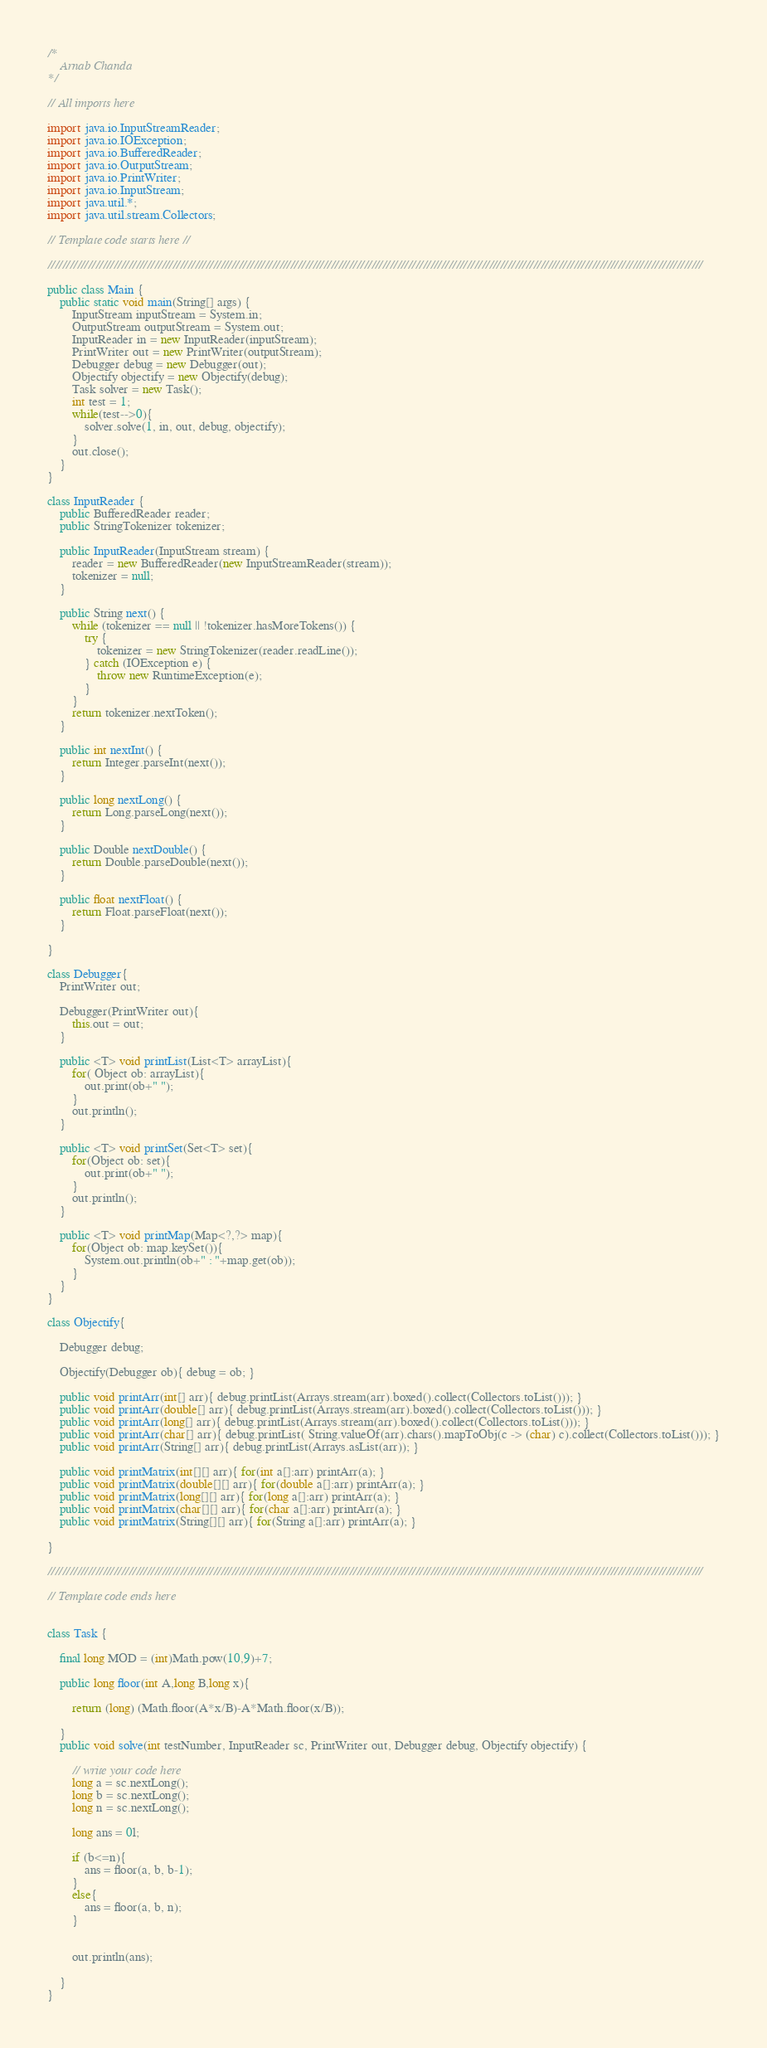<code> <loc_0><loc_0><loc_500><loc_500><_Java_>/*
    Arnab Chanda 
*/

// All imports here

import java.io.InputStreamReader;
import java.io.IOException;
import java.io.BufferedReader;
import java.io.OutputStream;
import java.io.PrintWriter;
import java.io.InputStream;
import java.util.*;
import java.util.stream.Collectors;

// Template code starts here //

//////////////////////////////////////////////////////////////////////////////////////////////////////////////////////////////////////////////////////////////////////////////////

public class Main {
	public static void main(String[] args) {
		InputStream inputStream = System.in;
		OutputStream outputStream = System.out;
		InputReader in = new InputReader(inputStream);
        PrintWriter out = new PrintWriter(outputStream);
        Debugger debug = new Debugger(out);
        Objectify objectify = new Objectify(debug);
        Task solver = new Task();
        int test = 1;
        while(test-->0){
            solver.solve(1, in, out, debug, objectify);
        }
		out.close();
	}
}

class InputReader {
    public BufferedReader reader;
    public StringTokenizer tokenizer;
 
    public InputReader(InputStream stream) {
        reader = new BufferedReader(new InputStreamReader(stream));
        tokenizer = null;
    }
 
    public String next() {
        while (tokenizer == null || !tokenizer.hasMoreTokens()) {
            try {
                tokenizer = new StringTokenizer(reader.readLine());
            } catch (IOException e) {
                throw new RuntimeException(e);
            }
        }
        return tokenizer.nextToken();
    }
 
    public int nextInt() {
        return Integer.parseInt(next());
    }

    public long nextLong() {
        return Long.parseLong(next());
    }

    public Double nextDouble() {
        return Double.parseDouble(next());
    }

    public float nextFloat() {
        return Float.parseFloat(next());
    }
 
}

class Debugger{
    PrintWriter out;

    Debugger(PrintWriter out){    
        this.out = out;
    }

    public <T> void printList(List<T> arrayList){
        for( Object ob: arrayList){
            out.print(ob+" ");
        }
        out.println();
    }

    public <T> void printSet(Set<T> set){
        for(Object ob: set){
            out.print(ob+" ");
        }
        out.println();
    }

    public <T> void printMap(Map<?,?> map){
        for(Object ob: map.keySet()){
            System.out.println(ob+" : "+map.get(ob));
        }
    }
}

class Objectify{
    
    Debugger debug;

    Objectify(Debugger ob){ debug = ob; }

    public void printArr(int[] arr){ debug.printList(Arrays.stream(arr).boxed().collect(Collectors.toList())); }
    public void printArr(double[] arr){ debug.printList(Arrays.stream(arr).boxed().collect(Collectors.toList())); }
    public void printArr(long[] arr){ debug.printList(Arrays.stream(arr).boxed().collect(Collectors.toList())); }
    public void printArr(char[] arr){ debug.printList( String.valueOf(arr).chars().mapToObj(c -> (char) c).collect(Collectors.toList())); }
    public void printArr(String[] arr){ debug.printList(Arrays.asList(arr)); }

    public void printMatrix(int[][] arr){ for(int a[]:arr) printArr(a); }
    public void printMatrix(double[][] arr){ for(double a[]:arr) printArr(a); }
    public void printMatrix(long[][] arr){ for(long a[]:arr) printArr(a); }
    public void printMatrix(char[][] arr){ for(char a[]:arr) printArr(a); }
    public void printMatrix(String[][] arr){ for(String a[]:arr) printArr(a); }

}

//////////////////////////////////////////////////////////////////////////////////////////////////////////////////////////////////////////////////////////////////////////////////

// Template code ends here


class Task {

    final long MOD = (int)Math.pow(10,9)+7;
    
    public long floor(int A,long B,long x){
 
        return (long) (Math.floor(A*x/B)-A*Math.floor(x/B));
 
    }
    public void solve(int testNumber, InputReader sc, PrintWriter out, Debugger debug, Objectify objectify) {
        
        // write your code here
        long a = sc.nextLong();
        long b = sc.nextLong();
        long n = sc.nextLong();

        long ans = 0l;

        if (b<=n){
            ans = floor(a, b, b-1);
        }
        else{
            ans = floor(a, b, n);
        }


        out.println(ans);
        
    }
}</code> 